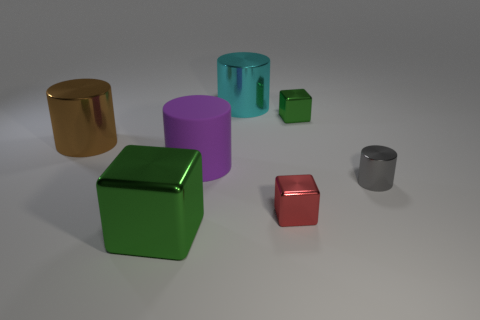Add 1 gray cylinders. How many objects exist? 8 Subtract all cylinders. How many objects are left? 3 Subtract 0 green spheres. How many objects are left? 7 Subtract all big green metal things. Subtract all large cyan metallic objects. How many objects are left? 5 Add 3 gray cylinders. How many gray cylinders are left? 4 Add 2 brown metallic blocks. How many brown metallic blocks exist? 2 